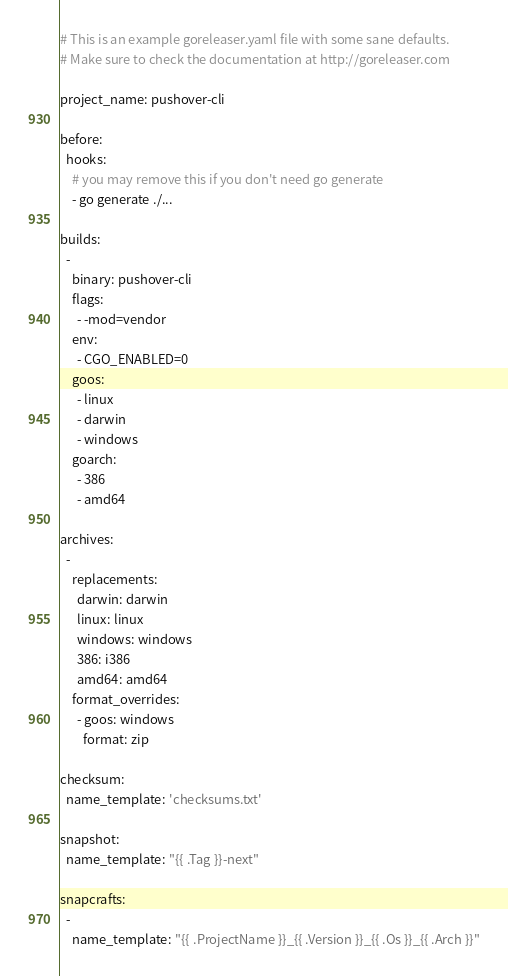<code> <loc_0><loc_0><loc_500><loc_500><_YAML_># This is an example goreleaser.yaml file with some sane defaults.
# Make sure to check the documentation at http://goreleaser.com

project_name: pushover-cli

before:
  hooks:
    # you may remove this if you don't need go generate
    - go generate ./...

builds:
  -
    binary: pushover-cli
    flags:
      - -mod=vendor
    env:
      - CGO_ENABLED=0
    goos:
      - linux
      - darwin
      - windows
    goarch:
      - 386
      - amd64

archives:
  -
    replacements:
      darwin: darwin
      linux: linux
      windows: windows
      386: i386
      amd64: amd64
    format_overrides:
      - goos: windows
        format: zip

checksum:
  name_template: 'checksums.txt'

snapshot:
  name_template: "{{ .Tag }}-next"

snapcrafts:
  -
    name_template: "{{ .ProjectName }}_{{ .Version }}_{{ .Os }}_{{ .Arch }}"</code> 